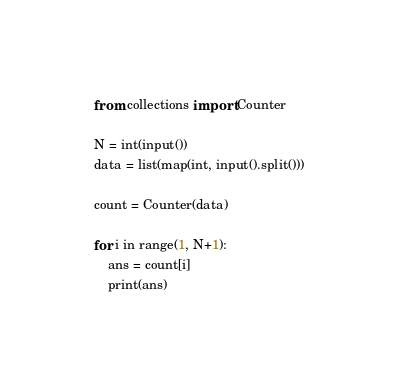<code> <loc_0><loc_0><loc_500><loc_500><_Python_>from collections import Counter

N = int(input())
data = list(map(int, input().split()))

count = Counter(data)

for i in range(1, N+1):
    ans = count[i]
    print(ans)
</code> 